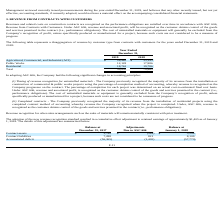From Sunworks's financial document, What are the two changes in accounting principles in adopting ASC 606? The document shows two values: Timing of revenue recognition for uninstalled materials and Completed contracts. From the document: "not considered to be a measure of progress. (ii) Completed contracts - The Company previously recognized the majority of its revenue from the installa..." Also, How is revenue recognised under ASC 606? revenue is recognized as the customer obtains control of the goods and services promised in the contract (i.e., performance obligations). The document states: "zed when the project is completed. Under, ASC 606, revenue is recognized as the customer obtains control of the goods and services promised in the con..." Also, What is the Contract assets balance at December 31, 2017?  According to the financial document, $3,790. The relevant text states: "Contract assets $ 3,790 $ (584) $ 3,206..." Also, can you calculate: What is the percentage change in the contract liabilities after adjustments due to ASC606? Based on the calculation: 821/7,288, the result is 11.27 (percentage). This is based on the information: "Contract liabilities 7,288 821 8,109 Contract liabilities 7,288 821 8,109..." The key data points involved are: 7,288, 821. Also, can you calculate: What is the percentage change in the contract assets after adjustments due to ASC606? To answer this question, I need to perform calculations using the financial data. The calculation is: -584/3,790, which equals -15.41 (percentage). This is based on the information: "Contract assets $ 3,790 $ (584) $ 3,206 Contract assets $ 3,790 $ (584) $ 3,206..." The key data points involved are: 3,790, 584. Also, can you calculate: What is the percentage change in the accumulated deficit after the adjustment? To answer this question, I need to perform calculations using the financial data. The calculation is: -1,405/-56,365, which equals 2.49 (percentage). This is based on the information: "Accumulated deficit (56,365) (1,405) (57,770) Accumulated deficit (56,365) (1,405) (57,770)..." The key data points involved are: 1,405, 56,365. 